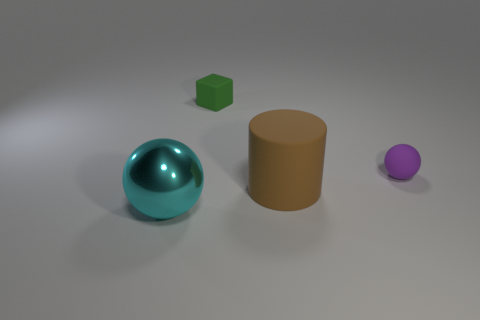Add 3 tiny blue balls. How many objects exist? 7 Subtract all cubes. How many objects are left? 3 Add 4 small green objects. How many small green objects are left? 5 Add 2 green things. How many green things exist? 3 Subtract 0 cyan cubes. How many objects are left? 4 Subtract all metal things. Subtract all big rubber objects. How many objects are left? 2 